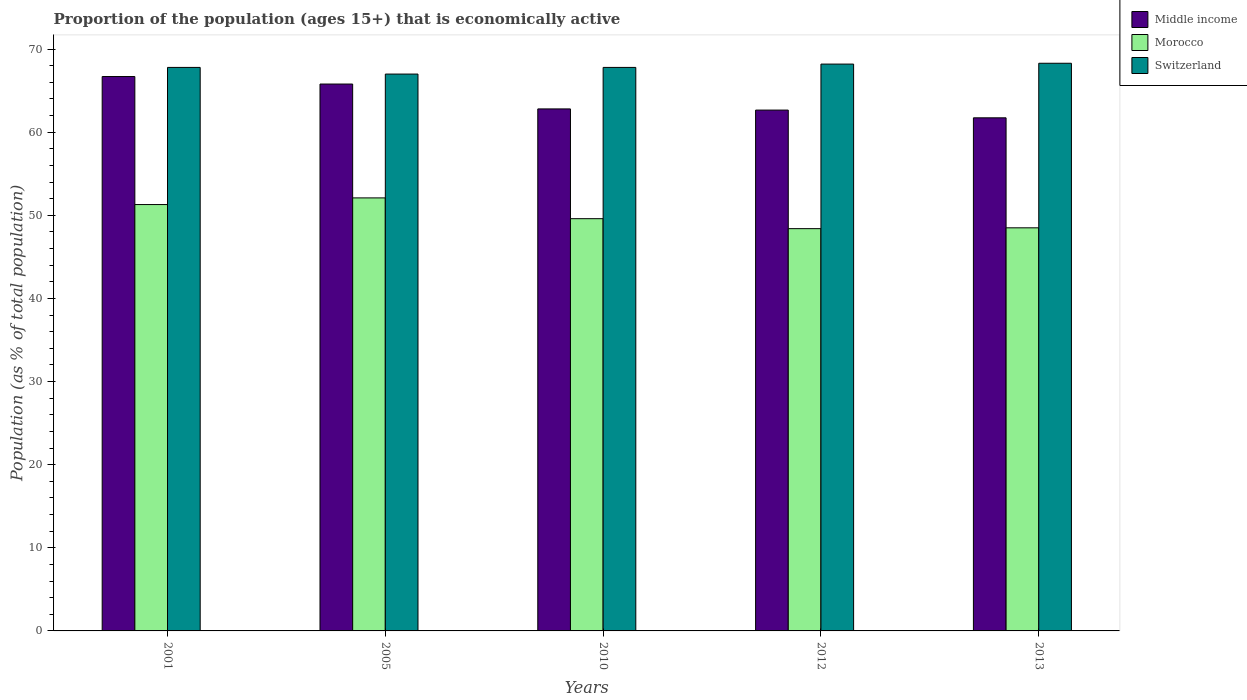How many different coloured bars are there?
Provide a short and direct response. 3. Are the number of bars per tick equal to the number of legend labels?
Ensure brevity in your answer.  Yes. Are the number of bars on each tick of the X-axis equal?
Make the answer very short. Yes. How many bars are there on the 2nd tick from the left?
Ensure brevity in your answer.  3. What is the proportion of the population that is economically active in Middle income in 2001?
Keep it short and to the point. 66.7. Across all years, what is the maximum proportion of the population that is economically active in Morocco?
Your answer should be very brief. 52.1. Across all years, what is the minimum proportion of the population that is economically active in Morocco?
Provide a short and direct response. 48.4. In which year was the proportion of the population that is economically active in Middle income maximum?
Your response must be concise. 2001. What is the total proportion of the population that is economically active in Middle income in the graph?
Keep it short and to the point. 319.71. What is the difference between the proportion of the population that is economically active in Morocco in 2005 and that in 2012?
Make the answer very short. 3.7. What is the difference between the proportion of the population that is economically active in Switzerland in 2012 and the proportion of the population that is economically active in Morocco in 2013?
Offer a terse response. 19.7. What is the average proportion of the population that is economically active in Middle income per year?
Ensure brevity in your answer.  63.94. In the year 2005, what is the difference between the proportion of the population that is economically active in Switzerland and proportion of the population that is economically active in Morocco?
Give a very brief answer. 14.9. What is the ratio of the proportion of the population that is economically active in Morocco in 2001 to that in 2005?
Offer a very short reply. 0.98. Is the proportion of the population that is economically active in Morocco in 2001 less than that in 2010?
Ensure brevity in your answer.  No. What is the difference between the highest and the second highest proportion of the population that is economically active in Morocco?
Provide a short and direct response. 0.8. What is the difference between the highest and the lowest proportion of the population that is economically active in Middle income?
Provide a succinct answer. 4.97. What does the 3rd bar from the left in 2001 represents?
Your answer should be very brief. Switzerland. What does the 3rd bar from the right in 2005 represents?
Your answer should be very brief. Middle income. Is it the case that in every year, the sum of the proportion of the population that is economically active in Middle income and proportion of the population that is economically active in Morocco is greater than the proportion of the population that is economically active in Switzerland?
Provide a short and direct response. Yes. How many years are there in the graph?
Your response must be concise. 5. What is the difference between two consecutive major ticks on the Y-axis?
Ensure brevity in your answer.  10. Are the values on the major ticks of Y-axis written in scientific E-notation?
Give a very brief answer. No. Does the graph contain any zero values?
Keep it short and to the point. No. How many legend labels are there?
Provide a succinct answer. 3. What is the title of the graph?
Give a very brief answer. Proportion of the population (ages 15+) that is economically active. Does "Sao Tome and Principe" appear as one of the legend labels in the graph?
Provide a short and direct response. No. What is the label or title of the X-axis?
Keep it short and to the point. Years. What is the label or title of the Y-axis?
Your response must be concise. Population (as % of total population). What is the Population (as % of total population) in Middle income in 2001?
Your answer should be compact. 66.7. What is the Population (as % of total population) in Morocco in 2001?
Provide a succinct answer. 51.3. What is the Population (as % of total population) in Switzerland in 2001?
Give a very brief answer. 67.8. What is the Population (as % of total population) of Middle income in 2005?
Keep it short and to the point. 65.8. What is the Population (as % of total population) of Morocco in 2005?
Offer a terse response. 52.1. What is the Population (as % of total population) of Switzerland in 2005?
Provide a short and direct response. 67. What is the Population (as % of total population) of Middle income in 2010?
Provide a succinct answer. 62.81. What is the Population (as % of total population) in Morocco in 2010?
Make the answer very short. 49.6. What is the Population (as % of total population) in Switzerland in 2010?
Your answer should be very brief. 67.8. What is the Population (as % of total population) of Middle income in 2012?
Your answer should be very brief. 62.66. What is the Population (as % of total population) in Morocco in 2012?
Keep it short and to the point. 48.4. What is the Population (as % of total population) in Switzerland in 2012?
Provide a succinct answer. 68.2. What is the Population (as % of total population) in Middle income in 2013?
Give a very brief answer. 61.74. What is the Population (as % of total population) of Morocco in 2013?
Your answer should be very brief. 48.5. What is the Population (as % of total population) in Switzerland in 2013?
Keep it short and to the point. 68.3. Across all years, what is the maximum Population (as % of total population) of Middle income?
Ensure brevity in your answer.  66.7. Across all years, what is the maximum Population (as % of total population) of Morocco?
Provide a succinct answer. 52.1. Across all years, what is the maximum Population (as % of total population) of Switzerland?
Provide a short and direct response. 68.3. Across all years, what is the minimum Population (as % of total population) in Middle income?
Make the answer very short. 61.74. Across all years, what is the minimum Population (as % of total population) in Morocco?
Offer a very short reply. 48.4. What is the total Population (as % of total population) of Middle income in the graph?
Offer a terse response. 319.71. What is the total Population (as % of total population) in Morocco in the graph?
Provide a short and direct response. 249.9. What is the total Population (as % of total population) of Switzerland in the graph?
Provide a succinct answer. 339.1. What is the difference between the Population (as % of total population) of Middle income in 2001 and that in 2005?
Keep it short and to the point. 0.9. What is the difference between the Population (as % of total population) of Switzerland in 2001 and that in 2005?
Make the answer very short. 0.8. What is the difference between the Population (as % of total population) of Middle income in 2001 and that in 2010?
Your response must be concise. 3.89. What is the difference between the Population (as % of total population) in Morocco in 2001 and that in 2010?
Your answer should be very brief. 1.7. What is the difference between the Population (as % of total population) in Middle income in 2001 and that in 2012?
Ensure brevity in your answer.  4.04. What is the difference between the Population (as % of total population) of Morocco in 2001 and that in 2012?
Ensure brevity in your answer.  2.9. What is the difference between the Population (as % of total population) of Switzerland in 2001 and that in 2012?
Offer a terse response. -0.4. What is the difference between the Population (as % of total population) of Middle income in 2001 and that in 2013?
Give a very brief answer. 4.97. What is the difference between the Population (as % of total population) in Morocco in 2001 and that in 2013?
Keep it short and to the point. 2.8. What is the difference between the Population (as % of total population) in Middle income in 2005 and that in 2010?
Offer a very short reply. 2.99. What is the difference between the Population (as % of total population) of Switzerland in 2005 and that in 2010?
Your answer should be compact. -0.8. What is the difference between the Population (as % of total population) in Middle income in 2005 and that in 2012?
Your answer should be compact. 3.13. What is the difference between the Population (as % of total population) of Morocco in 2005 and that in 2012?
Your answer should be compact. 3.7. What is the difference between the Population (as % of total population) of Middle income in 2005 and that in 2013?
Keep it short and to the point. 4.06. What is the difference between the Population (as % of total population) in Morocco in 2005 and that in 2013?
Your response must be concise. 3.6. What is the difference between the Population (as % of total population) in Switzerland in 2005 and that in 2013?
Provide a short and direct response. -1.3. What is the difference between the Population (as % of total population) in Middle income in 2010 and that in 2012?
Keep it short and to the point. 0.14. What is the difference between the Population (as % of total population) in Switzerland in 2010 and that in 2012?
Offer a terse response. -0.4. What is the difference between the Population (as % of total population) of Middle income in 2010 and that in 2013?
Your answer should be compact. 1.07. What is the difference between the Population (as % of total population) of Switzerland in 2010 and that in 2013?
Your response must be concise. -0.5. What is the difference between the Population (as % of total population) in Middle income in 2012 and that in 2013?
Your answer should be very brief. 0.93. What is the difference between the Population (as % of total population) in Morocco in 2012 and that in 2013?
Make the answer very short. -0.1. What is the difference between the Population (as % of total population) in Middle income in 2001 and the Population (as % of total population) in Morocco in 2005?
Offer a very short reply. 14.6. What is the difference between the Population (as % of total population) in Middle income in 2001 and the Population (as % of total population) in Switzerland in 2005?
Your response must be concise. -0.3. What is the difference between the Population (as % of total population) of Morocco in 2001 and the Population (as % of total population) of Switzerland in 2005?
Give a very brief answer. -15.7. What is the difference between the Population (as % of total population) of Middle income in 2001 and the Population (as % of total population) of Morocco in 2010?
Offer a very short reply. 17.1. What is the difference between the Population (as % of total population) in Middle income in 2001 and the Population (as % of total population) in Switzerland in 2010?
Your response must be concise. -1.1. What is the difference between the Population (as % of total population) of Morocco in 2001 and the Population (as % of total population) of Switzerland in 2010?
Offer a terse response. -16.5. What is the difference between the Population (as % of total population) of Middle income in 2001 and the Population (as % of total population) of Morocco in 2012?
Provide a short and direct response. 18.3. What is the difference between the Population (as % of total population) in Middle income in 2001 and the Population (as % of total population) in Switzerland in 2012?
Your response must be concise. -1.5. What is the difference between the Population (as % of total population) of Morocco in 2001 and the Population (as % of total population) of Switzerland in 2012?
Your response must be concise. -16.9. What is the difference between the Population (as % of total population) of Middle income in 2001 and the Population (as % of total population) of Morocco in 2013?
Provide a succinct answer. 18.2. What is the difference between the Population (as % of total population) in Middle income in 2001 and the Population (as % of total population) in Switzerland in 2013?
Your response must be concise. -1.6. What is the difference between the Population (as % of total population) in Morocco in 2001 and the Population (as % of total population) in Switzerland in 2013?
Offer a terse response. -17. What is the difference between the Population (as % of total population) in Middle income in 2005 and the Population (as % of total population) in Morocco in 2010?
Ensure brevity in your answer.  16.2. What is the difference between the Population (as % of total population) of Middle income in 2005 and the Population (as % of total population) of Switzerland in 2010?
Your answer should be very brief. -2. What is the difference between the Population (as % of total population) in Morocco in 2005 and the Population (as % of total population) in Switzerland in 2010?
Ensure brevity in your answer.  -15.7. What is the difference between the Population (as % of total population) of Middle income in 2005 and the Population (as % of total population) of Morocco in 2012?
Provide a short and direct response. 17.4. What is the difference between the Population (as % of total population) in Middle income in 2005 and the Population (as % of total population) in Switzerland in 2012?
Keep it short and to the point. -2.4. What is the difference between the Population (as % of total population) in Morocco in 2005 and the Population (as % of total population) in Switzerland in 2012?
Your response must be concise. -16.1. What is the difference between the Population (as % of total population) of Middle income in 2005 and the Population (as % of total population) of Morocco in 2013?
Provide a succinct answer. 17.3. What is the difference between the Population (as % of total population) in Middle income in 2005 and the Population (as % of total population) in Switzerland in 2013?
Offer a terse response. -2.5. What is the difference between the Population (as % of total population) in Morocco in 2005 and the Population (as % of total population) in Switzerland in 2013?
Offer a very short reply. -16.2. What is the difference between the Population (as % of total population) in Middle income in 2010 and the Population (as % of total population) in Morocco in 2012?
Ensure brevity in your answer.  14.41. What is the difference between the Population (as % of total population) of Middle income in 2010 and the Population (as % of total population) of Switzerland in 2012?
Ensure brevity in your answer.  -5.39. What is the difference between the Population (as % of total population) of Morocco in 2010 and the Population (as % of total population) of Switzerland in 2012?
Ensure brevity in your answer.  -18.6. What is the difference between the Population (as % of total population) in Middle income in 2010 and the Population (as % of total population) in Morocco in 2013?
Give a very brief answer. 14.31. What is the difference between the Population (as % of total population) in Middle income in 2010 and the Population (as % of total population) in Switzerland in 2013?
Make the answer very short. -5.49. What is the difference between the Population (as % of total population) of Morocco in 2010 and the Population (as % of total population) of Switzerland in 2013?
Provide a succinct answer. -18.7. What is the difference between the Population (as % of total population) in Middle income in 2012 and the Population (as % of total population) in Morocco in 2013?
Provide a short and direct response. 14.16. What is the difference between the Population (as % of total population) of Middle income in 2012 and the Population (as % of total population) of Switzerland in 2013?
Keep it short and to the point. -5.64. What is the difference between the Population (as % of total population) in Morocco in 2012 and the Population (as % of total population) in Switzerland in 2013?
Make the answer very short. -19.9. What is the average Population (as % of total population) of Middle income per year?
Your answer should be very brief. 63.94. What is the average Population (as % of total population) of Morocco per year?
Offer a very short reply. 49.98. What is the average Population (as % of total population) of Switzerland per year?
Provide a short and direct response. 67.82. In the year 2001, what is the difference between the Population (as % of total population) in Middle income and Population (as % of total population) in Morocco?
Ensure brevity in your answer.  15.4. In the year 2001, what is the difference between the Population (as % of total population) in Middle income and Population (as % of total population) in Switzerland?
Keep it short and to the point. -1.1. In the year 2001, what is the difference between the Population (as % of total population) of Morocco and Population (as % of total population) of Switzerland?
Ensure brevity in your answer.  -16.5. In the year 2005, what is the difference between the Population (as % of total population) in Middle income and Population (as % of total population) in Morocco?
Your answer should be very brief. 13.7. In the year 2005, what is the difference between the Population (as % of total population) in Middle income and Population (as % of total population) in Switzerland?
Make the answer very short. -1.2. In the year 2005, what is the difference between the Population (as % of total population) in Morocco and Population (as % of total population) in Switzerland?
Ensure brevity in your answer.  -14.9. In the year 2010, what is the difference between the Population (as % of total population) of Middle income and Population (as % of total population) of Morocco?
Offer a very short reply. 13.21. In the year 2010, what is the difference between the Population (as % of total population) in Middle income and Population (as % of total population) in Switzerland?
Offer a terse response. -4.99. In the year 2010, what is the difference between the Population (as % of total population) of Morocco and Population (as % of total population) of Switzerland?
Your answer should be compact. -18.2. In the year 2012, what is the difference between the Population (as % of total population) of Middle income and Population (as % of total population) of Morocco?
Your response must be concise. 14.26. In the year 2012, what is the difference between the Population (as % of total population) in Middle income and Population (as % of total population) in Switzerland?
Make the answer very short. -5.54. In the year 2012, what is the difference between the Population (as % of total population) in Morocco and Population (as % of total population) in Switzerland?
Make the answer very short. -19.8. In the year 2013, what is the difference between the Population (as % of total population) in Middle income and Population (as % of total population) in Morocco?
Offer a very short reply. 13.24. In the year 2013, what is the difference between the Population (as % of total population) of Middle income and Population (as % of total population) of Switzerland?
Provide a short and direct response. -6.56. In the year 2013, what is the difference between the Population (as % of total population) in Morocco and Population (as % of total population) in Switzerland?
Offer a terse response. -19.8. What is the ratio of the Population (as % of total population) in Middle income in 2001 to that in 2005?
Offer a very short reply. 1.01. What is the ratio of the Population (as % of total population) of Morocco in 2001 to that in 2005?
Give a very brief answer. 0.98. What is the ratio of the Population (as % of total population) of Switzerland in 2001 to that in 2005?
Ensure brevity in your answer.  1.01. What is the ratio of the Population (as % of total population) in Middle income in 2001 to that in 2010?
Offer a very short reply. 1.06. What is the ratio of the Population (as % of total population) of Morocco in 2001 to that in 2010?
Keep it short and to the point. 1.03. What is the ratio of the Population (as % of total population) in Switzerland in 2001 to that in 2010?
Your answer should be compact. 1. What is the ratio of the Population (as % of total population) of Middle income in 2001 to that in 2012?
Provide a succinct answer. 1.06. What is the ratio of the Population (as % of total population) of Morocco in 2001 to that in 2012?
Give a very brief answer. 1.06. What is the ratio of the Population (as % of total population) in Switzerland in 2001 to that in 2012?
Offer a very short reply. 0.99. What is the ratio of the Population (as % of total population) in Middle income in 2001 to that in 2013?
Provide a succinct answer. 1.08. What is the ratio of the Population (as % of total population) of Morocco in 2001 to that in 2013?
Keep it short and to the point. 1.06. What is the ratio of the Population (as % of total population) in Switzerland in 2001 to that in 2013?
Make the answer very short. 0.99. What is the ratio of the Population (as % of total population) of Middle income in 2005 to that in 2010?
Give a very brief answer. 1.05. What is the ratio of the Population (as % of total population) of Morocco in 2005 to that in 2010?
Your answer should be compact. 1.05. What is the ratio of the Population (as % of total population) in Switzerland in 2005 to that in 2010?
Offer a very short reply. 0.99. What is the ratio of the Population (as % of total population) in Morocco in 2005 to that in 2012?
Your answer should be very brief. 1.08. What is the ratio of the Population (as % of total population) in Switzerland in 2005 to that in 2012?
Your response must be concise. 0.98. What is the ratio of the Population (as % of total population) in Middle income in 2005 to that in 2013?
Offer a terse response. 1.07. What is the ratio of the Population (as % of total population) in Morocco in 2005 to that in 2013?
Your response must be concise. 1.07. What is the ratio of the Population (as % of total population) in Switzerland in 2005 to that in 2013?
Your response must be concise. 0.98. What is the ratio of the Population (as % of total population) of Middle income in 2010 to that in 2012?
Offer a very short reply. 1. What is the ratio of the Population (as % of total population) of Morocco in 2010 to that in 2012?
Your answer should be compact. 1.02. What is the ratio of the Population (as % of total population) in Middle income in 2010 to that in 2013?
Ensure brevity in your answer.  1.02. What is the ratio of the Population (as % of total population) in Morocco in 2010 to that in 2013?
Offer a very short reply. 1.02. What is the ratio of the Population (as % of total population) in Middle income in 2012 to that in 2013?
Your answer should be very brief. 1.02. What is the ratio of the Population (as % of total population) in Morocco in 2012 to that in 2013?
Make the answer very short. 1. What is the ratio of the Population (as % of total population) in Switzerland in 2012 to that in 2013?
Provide a short and direct response. 1. What is the difference between the highest and the second highest Population (as % of total population) of Middle income?
Provide a short and direct response. 0.9. What is the difference between the highest and the second highest Population (as % of total population) in Switzerland?
Offer a very short reply. 0.1. What is the difference between the highest and the lowest Population (as % of total population) in Middle income?
Your answer should be very brief. 4.97. What is the difference between the highest and the lowest Population (as % of total population) of Morocco?
Your answer should be compact. 3.7. 